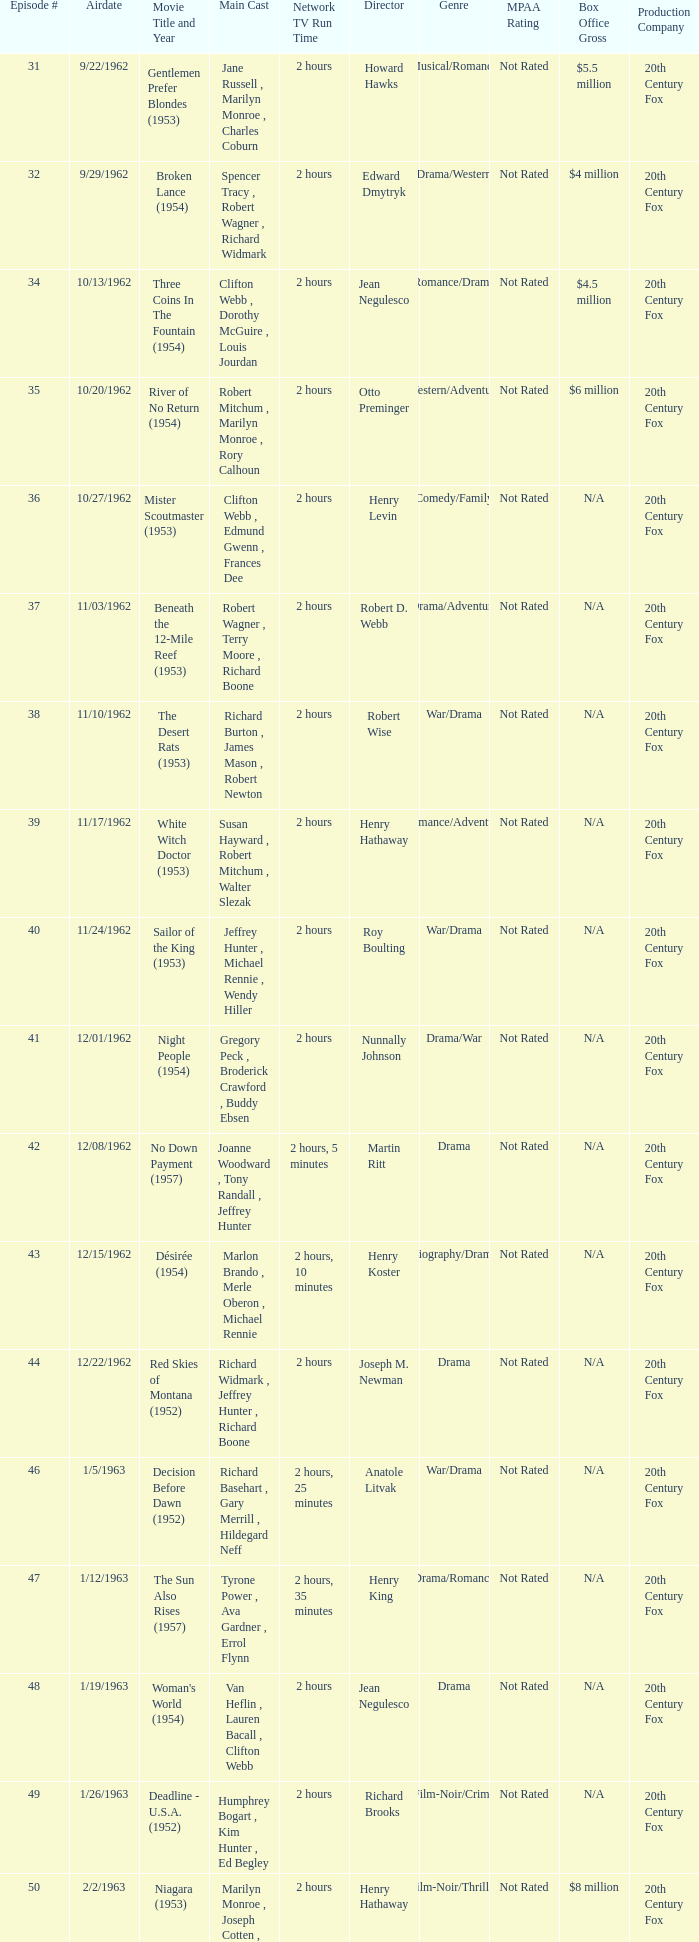Who was the cast on the 3/23/1963 episode? Dana Wynter , Mel Ferrer , Theodore Bikel. 